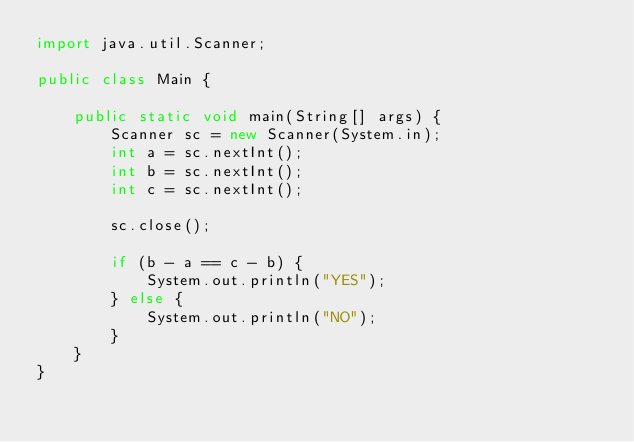<code> <loc_0><loc_0><loc_500><loc_500><_Java_>import java.util.Scanner;

public class Main {

    public static void main(String[] args) {
        Scanner sc = new Scanner(System.in);
        int a = sc.nextInt();
        int b = sc.nextInt();
        int c = sc.nextInt();

        sc.close();

        if (b - a == c - b) {
            System.out.println("YES");
        } else {
            System.out.println("NO");
        }
    }
}</code> 